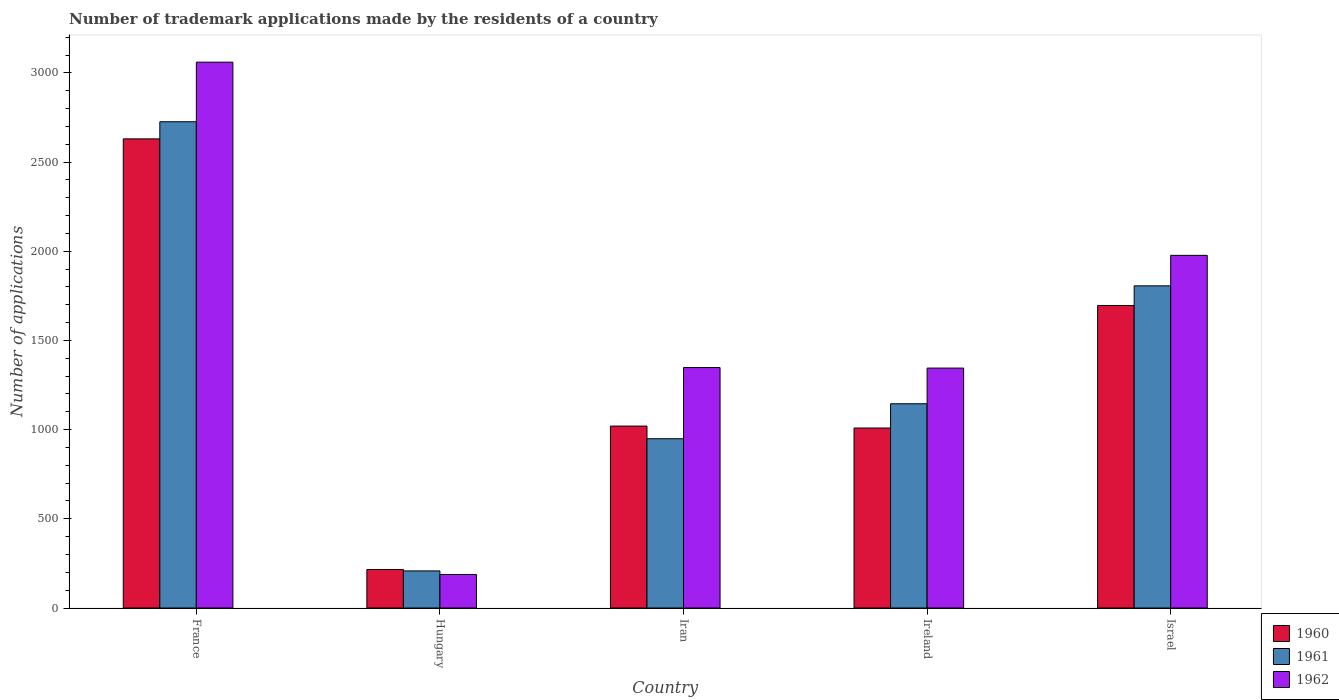Are the number of bars per tick equal to the number of legend labels?
Provide a succinct answer. Yes. Are the number of bars on each tick of the X-axis equal?
Your response must be concise. Yes. How many bars are there on the 1st tick from the left?
Offer a very short reply. 3. What is the label of the 3rd group of bars from the left?
Provide a short and direct response. Iran. What is the number of trademark applications made by the residents in 1962 in Hungary?
Offer a terse response. 188. Across all countries, what is the maximum number of trademark applications made by the residents in 1962?
Give a very brief answer. 3060. Across all countries, what is the minimum number of trademark applications made by the residents in 1960?
Provide a succinct answer. 216. In which country was the number of trademark applications made by the residents in 1960 minimum?
Offer a terse response. Hungary. What is the total number of trademark applications made by the residents in 1962 in the graph?
Provide a succinct answer. 7918. What is the difference between the number of trademark applications made by the residents in 1962 in Hungary and that in Iran?
Offer a terse response. -1160. What is the difference between the number of trademark applications made by the residents in 1960 in Iran and the number of trademark applications made by the residents in 1962 in Israel?
Offer a very short reply. -957. What is the average number of trademark applications made by the residents in 1960 per country?
Your response must be concise. 1314.2. What is the difference between the number of trademark applications made by the residents of/in 1962 and number of trademark applications made by the residents of/in 1961 in Israel?
Give a very brief answer. 171. In how many countries, is the number of trademark applications made by the residents in 1961 greater than 3100?
Offer a very short reply. 0. What is the ratio of the number of trademark applications made by the residents in 1960 in Iran to that in Israel?
Provide a short and direct response. 0.6. Is the difference between the number of trademark applications made by the residents in 1962 in Iran and Ireland greater than the difference between the number of trademark applications made by the residents in 1961 in Iran and Ireland?
Offer a very short reply. Yes. What is the difference between the highest and the second highest number of trademark applications made by the residents in 1961?
Ensure brevity in your answer.  -1581. What is the difference between the highest and the lowest number of trademark applications made by the residents in 1962?
Ensure brevity in your answer.  2872. In how many countries, is the number of trademark applications made by the residents in 1962 greater than the average number of trademark applications made by the residents in 1962 taken over all countries?
Offer a terse response. 2. Is the sum of the number of trademark applications made by the residents in 1961 in France and Ireland greater than the maximum number of trademark applications made by the residents in 1960 across all countries?
Offer a very short reply. Yes. Is it the case that in every country, the sum of the number of trademark applications made by the residents in 1962 and number of trademark applications made by the residents in 1961 is greater than the number of trademark applications made by the residents in 1960?
Make the answer very short. Yes. Are all the bars in the graph horizontal?
Provide a short and direct response. No. What is the difference between two consecutive major ticks on the Y-axis?
Keep it short and to the point. 500. Does the graph contain any zero values?
Your response must be concise. No. Does the graph contain grids?
Keep it short and to the point. No. Where does the legend appear in the graph?
Keep it short and to the point. Bottom right. How many legend labels are there?
Provide a short and direct response. 3. How are the legend labels stacked?
Your response must be concise. Vertical. What is the title of the graph?
Your response must be concise. Number of trademark applications made by the residents of a country. What is the label or title of the Y-axis?
Offer a very short reply. Number of applications. What is the Number of applications of 1960 in France?
Your response must be concise. 2630. What is the Number of applications in 1961 in France?
Your response must be concise. 2726. What is the Number of applications of 1962 in France?
Ensure brevity in your answer.  3060. What is the Number of applications in 1960 in Hungary?
Your answer should be compact. 216. What is the Number of applications of 1961 in Hungary?
Provide a succinct answer. 208. What is the Number of applications in 1962 in Hungary?
Provide a short and direct response. 188. What is the Number of applications of 1960 in Iran?
Your answer should be compact. 1020. What is the Number of applications in 1961 in Iran?
Offer a very short reply. 949. What is the Number of applications of 1962 in Iran?
Ensure brevity in your answer.  1348. What is the Number of applications in 1960 in Ireland?
Offer a very short reply. 1009. What is the Number of applications of 1961 in Ireland?
Make the answer very short. 1145. What is the Number of applications of 1962 in Ireland?
Make the answer very short. 1345. What is the Number of applications of 1960 in Israel?
Your answer should be compact. 1696. What is the Number of applications in 1961 in Israel?
Provide a succinct answer. 1806. What is the Number of applications of 1962 in Israel?
Make the answer very short. 1977. Across all countries, what is the maximum Number of applications of 1960?
Keep it short and to the point. 2630. Across all countries, what is the maximum Number of applications of 1961?
Keep it short and to the point. 2726. Across all countries, what is the maximum Number of applications of 1962?
Your answer should be compact. 3060. Across all countries, what is the minimum Number of applications in 1960?
Give a very brief answer. 216. Across all countries, what is the minimum Number of applications of 1961?
Ensure brevity in your answer.  208. Across all countries, what is the minimum Number of applications in 1962?
Provide a succinct answer. 188. What is the total Number of applications of 1960 in the graph?
Your answer should be compact. 6571. What is the total Number of applications of 1961 in the graph?
Give a very brief answer. 6834. What is the total Number of applications in 1962 in the graph?
Offer a terse response. 7918. What is the difference between the Number of applications of 1960 in France and that in Hungary?
Offer a terse response. 2414. What is the difference between the Number of applications in 1961 in France and that in Hungary?
Provide a short and direct response. 2518. What is the difference between the Number of applications of 1962 in France and that in Hungary?
Offer a very short reply. 2872. What is the difference between the Number of applications of 1960 in France and that in Iran?
Ensure brevity in your answer.  1610. What is the difference between the Number of applications in 1961 in France and that in Iran?
Ensure brevity in your answer.  1777. What is the difference between the Number of applications of 1962 in France and that in Iran?
Provide a short and direct response. 1712. What is the difference between the Number of applications in 1960 in France and that in Ireland?
Ensure brevity in your answer.  1621. What is the difference between the Number of applications of 1961 in France and that in Ireland?
Offer a very short reply. 1581. What is the difference between the Number of applications of 1962 in France and that in Ireland?
Offer a terse response. 1715. What is the difference between the Number of applications in 1960 in France and that in Israel?
Offer a terse response. 934. What is the difference between the Number of applications in 1961 in France and that in Israel?
Offer a terse response. 920. What is the difference between the Number of applications in 1962 in France and that in Israel?
Your answer should be compact. 1083. What is the difference between the Number of applications of 1960 in Hungary and that in Iran?
Offer a very short reply. -804. What is the difference between the Number of applications in 1961 in Hungary and that in Iran?
Provide a short and direct response. -741. What is the difference between the Number of applications of 1962 in Hungary and that in Iran?
Offer a terse response. -1160. What is the difference between the Number of applications in 1960 in Hungary and that in Ireland?
Ensure brevity in your answer.  -793. What is the difference between the Number of applications in 1961 in Hungary and that in Ireland?
Offer a very short reply. -937. What is the difference between the Number of applications in 1962 in Hungary and that in Ireland?
Offer a terse response. -1157. What is the difference between the Number of applications of 1960 in Hungary and that in Israel?
Offer a terse response. -1480. What is the difference between the Number of applications in 1961 in Hungary and that in Israel?
Provide a short and direct response. -1598. What is the difference between the Number of applications of 1962 in Hungary and that in Israel?
Make the answer very short. -1789. What is the difference between the Number of applications of 1960 in Iran and that in Ireland?
Keep it short and to the point. 11. What is the difference between the Number of applications in 1961 in Iran and that in Ireland?
Make the answer very short. -196. What is the difference between the Number of applications of 1960 in Iran and that in Israel?
Your answer should be compact. -676. What is the difference between the Number of applications of 1961 in Iran and that in Israel?
Ensure brevity in your answer.  -857. What is the difference between the Number of applications in 1962 in Iran and that in Israel?
Keep it short and to the point. -629. What is the difference between the Number of applications in 1960 in Ireland and that in Israel?
Your answer should be compact. -687. What is the difference between the Number of applications in 1961 in Ireland and that in Israel?
Make the answer very short. -661. What is the difference between the Number of applications in 1962 in Ireland and that in Israel?
Give a very brief answer. -632. What is the difference between the Number of applications in 1960 in France and the Number of applications in 1961 in Hungary?
Keep it short and to the point. 2422. What is the difference between the Number of applications in 1960 in France and the Number of applications in 1962 in Hungary?
Offer a terse response. 2442. What is the difference between the Number of applications in 1961 in France and the Number of applications in 1962 in Hungary?
Ensure brevity in your answer.  2538. What is the difference between the Number of applications of 1960 in France and the Number of applications of 1961 in Iran?
Provide a short and direct response. 1681. What is the difference between the Number of applications of 1960 in France and the Number of applications of 1962 in Iran?
Provide a short and direct response. 1282. What is the difference between the Number of applications in 1961 in France and the Number of applications in 1962 in Iran?
Make the answer very short. 1378. What is the difference between the Number of applications of 1960 in France and the Number of applications of 1961 in Ireland?
Keep it short and to the point. 1485. What is the difference between the Number of applications in 1960 in France and the Number of applications in 1962 in Ireland?
Provide a short and direct response. 1285. What is the difference between the Number of applications in 1961 in France and the Number of applications in 1962 in Ireland?
Make the answer very short. 1381. What is the difference between the Number of applications in 1960 in France and the Number of applications in 1961 in Israel?
Provide a succinct answer. 824. What is the difference between the Number of applications in 1960 in France and the Number of applications in 1962 in Israel?
Provide a short and direct response. 653. What is the difference between the Number of applications of 1961 in France and the Number of applications of 1962 in Israel?
Provide a short and direct response. 749. What is the difference between the Number of applications of 1960 in Hungary and the Number of applications of 1961 in Iran?
Keep it short and to the point. -733. What is the difference between the Number of applications of 1960 in Hungary and the Number of applications of 1962 in Iran?
Keep it short and to the point. -1132. What is the difference between the Number of applications in 1961 in Hungary and the Number of applications in 1962 in Iran?
Your answer should be compact. -1140. What is the difference between the Number of applications of 1960 in Hungary and the Number of applications of 1961 in Ireland?
Provide a short and direct response. -929. What is the difference between the Number of applications in 1960 in Hungary and the Number of applications in 1962 in Ireland?
Ensure brevity in your answer.  -1129. What is the difference between the Number of applications in 1961 in Hungary and the Number of applications in 1962 in Ireland?
Offer a terse response. -1137. What is the difference between the Number of applications in 1960 in Hungary and the Number of applications in 1961 in Israel?
Your answer should be very brief. -1590. What is the difference between the Number of applications of 1960 in Hungary and the Number of applications of 1962 in Israel?
Provide a succinct answer. -1761. What is the difference between the Number of applications of 1961 in Hungary and the Number of applications of 1962 in Israel?
Offer a very short reply. -1769. What is the difference between the Number of applications in 1960 in Iran and the Number of applications in 1961 in Ireland?
Make the answer very short. -125. What is the difference between the Number of applications of 1960 in Iran and the Number of applications of 1962 in Ireland?
Ensure brevity in your answer.  -325. What is the difference between the Number of applications of 1961 in Iran and the Number of applications of 1962 in Ireland?
Offer a very short reply. -396. What is the difference between the Number of applications of 1960 in Iran and the Number of applications of 1961 in Israel?
Make the answer very short. -786. What is the difference between the Number of applications of 1960 in Iran and the Number of applications of 1962 in Israel?
Keep it short and to the point. -957. What is the difference between the Number of applications of 1961 in Iran and the Number of applications of 1962 in Israel?
Give a very brief answer. -1028. What is the difference between the Number of applications of 1960 in Ireland and the Number of applications of 1961 in Israel?
Your answer should be very brief. -797. What is the difference between the Number of applications in 1960 in Ireland and the Number of applications in 1962 in Israel?
Provide a succinct answer. -968. What is the difference between the Number of applications in 1961 in Ireland and the Number of applications in 1962 in Israel?
Keep it short and to the point. -832. What is the average Number of applications in 1960 per country?
Offer a terse response. 1314.2. What is the average Number of applications of 1961 per country?
Keep it short and to the point. 1366.8. What is the average Number of applications of 1962 per country?
Give a very brief answer. 1583.6. What is the difference between the Number of applications of 1960 and Number of applications of 1961 in France?
Keep it short and to the point. -96. What is the difference between the Number of applications of 1960 and Number of applications of 1962 in France?
Your answer should be compact. -430. What is the difference between the Number of applications of 1961 and Number of applications of 1962 in France?
Your answer should be very brief. -334. What is the difference between the Number of applications of 1960 and Number of applications of 1962 in Hungary?
Offer a very short reply. 28. What is the difference between the Number of applications in 1960 and Number of applications in 1962 in Iran?
Offer a terse response. -328. What is the difference between the Number of applications in 1961 and Number of applications in 1962 in Iran?
Your answer should be very brief. -399. What is the difference between the Number of applications of 1960 and Number of applications of 1961 in Ireland?
Your response must be concise. -136. What is the difference between the Number of applications of 1960 and Number of applications of 1962 in Ireland?
Offer a very short reply. -336. What is the difference between the Number of applications in 1961 and Number of applications in 1962 in Ireland?
Your answer should be very brief. -200. What is the difference between the Number of applications in 1960 and Number of applications in 1961 in Israel?
Provide a short and direct response. -110. What is the difference between the Number of applications of 1960 and Number of applications of 1962 in Israel?
Keep it short and to the point. -281. What is the difference between the Number of applications in 1961 and Number of applications in 1962 in Israel?
Make the answer very short. -171. What is the ratio of the Number of applications in 1960 in France to that in Hungary?
Provide a short and direct response. 12.18. What is the ratio of the Number of applications in 1961 in France to that in Hungary?
Offer a terse response. 13.11. What is the ratio of the Number of applications of 1962 in France to that in Hungary?
Your answer should be very brief. 16.28. What is the ratio of the Number of applications of 1960 in France to that in Iran?
Provide a short and direct response. 2.58. What is the ratio of the Number of applications of 1961 in France to that in Iran?
Offer a terse response. 2.87. What is the ratio of the Number of applications of 1962 in France to that in Iran?
Give a very brief answer. 2.27. What is the ratio of the Number of applications of 1960 in France to that in Ireland?
Your answer should be compact. 2.61. What is the ratio of the Number of applications of 1961 in France to that in Ireland?
Keep it short and to the point. 2.38. What is the ratio of the Number of applications of 1962 in France to that in Ireland?
Your answer should be compact. 2.28. What is the ratio of the Number of applications of 1960 in France to that in Israel?
Ensure brevity in your answer.  1.55. What is the ratio of the Number of applications in 1961 in France to that in Israel?
Keep it short and to the point. 1.51. What is the ratio of the Number of applications in 1962 in France to that in Israel?
Provide a short and direct response. 1.55. What is the ratio of the Number of applications of 1960 in Hungary to that in Iran?
Your response must be concise. 0.21. What is the ratio of the Number of applications in 1961 in Hungary to that in Iran?
Keep it short and to the point. 0.22. What is the ratio of the Number of applications in 1962 in Hungary to that in Iran?
Your answer should be compact. 0.14. What is the ratio of the Number of applications of 1960 in Hungary to that in Ireland?
Make the answer very short. 0.21. What is the ratio of the Number of applications of 1961 in Hungary to that in Ireland?
Keep it short and to the point. 0.18. What is the ratio of the Number of applications in 1962 in Hungary to that in Ireland?
Provide a succinct answer. 0.14. What is the ratio of the Number of applications in 1960 in Hungary to that in Israel?
Your answer should be compact. 0.13. What is the ratio of the Number of applications of 1961 in Hungary to that in Israel?
Your answer should be compact. 0.12. What is the ratio of the Number of applications in 1962 in Hungary to that in Israel?
Your answer should be very brief. 0.1. What is the ratio of the Number of applications of 1960 in Iran to that in Ireland?
Give a very brief answer. 1.01. What is the ratio of the Number of applications in 1961 in Iran to that in Ireland?
Give a very brief answer. 0.83. What is the ratio of the Number of applications in 1962 in Iran to that in Ireland?
Provide a succinct answer. 1. What is the ratio of the Number of applications of 1960 in Iran to that in Israel?
Offer a terse response. 0.6. What is the ratio of the Number of applications in 1961 in Iran to that in Israel?
Keep it short and to the point. 0.53. What is the ratio of the Number of applications in 1962 in Iran to that in Israel?
Offer a very short reply. 0.68. What is the ratio of the Number of applications in 1960 in Ireland to that in Israel?
Your answer should be compact. 0.59. What is the ratio of the Number of applications in 1961 in Ireland to that in Israel?
Make the answer very short. 0.63. What is the ratio of the Number of applications of 1962 in Ireland to that in Israel?
Offer a terse response. 0.68. What is the difference between the highest and the second highest Number of applications of 1960?
Make the answer very short. 934. What is the difference between the highest and the second highest Number of applications of 1961?
Provide a short and direct response. 920. What is the difference between the highest and the second highest Number of applications in 1962?
Give a very brief answer. 1083. What is the difference between the highest and the lowest Number of applications in 1960?
Your answer should be compact. 2414. What is the difference between the highest and the lowest Number of applications in 1961?
Make the answer very short. 2518. What is the difference between the highest and the lowest Number of applications in 1962?
Ensure brevity in your answer.  2872. 